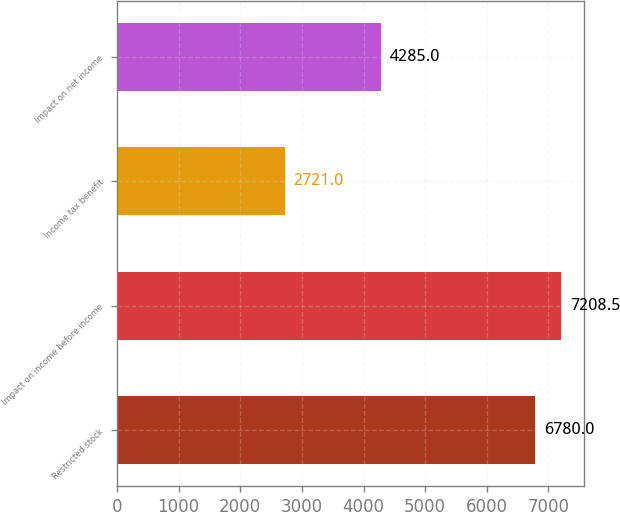Convert chart to OTSL. <chart><loc_0><loc_0><loc_500><loc_500><bar_chart><fcel>Restricted stock<fcel>Impact on income before income<fcel>Income tax benefit<fcel>Impact on net income<nl><fcel>6780<fcel>7208.5<fcel>2721<fcel>4285<nl></chart> 